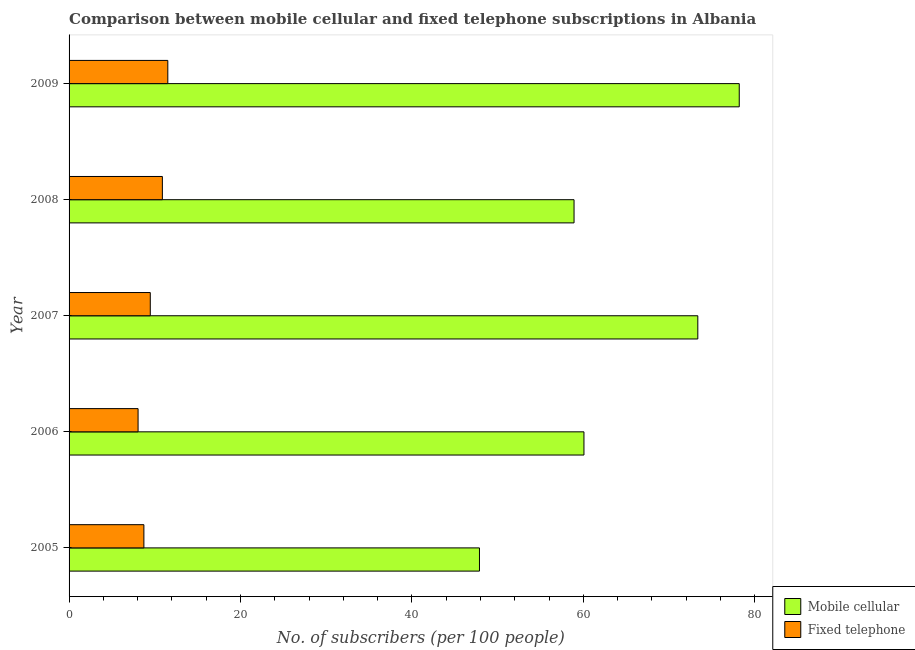How many different coloured bars are there?
Your answer should be very brief. 2. How many bars are there on the 3rd tick from the bottom?
Provide a succinct answer. 2. What is the label of the 4th group of bars from the top?
Offer a very short reply. 2006. What is the number of fixed telephone subscribers in 2005?
Provide a short and direct response. 8.73. Across all years, what is the maximum number of mobile cellular subscribers?
Offer a terse response. 78.18. Across all years, what is the minimum number of fixed telephone subscribers?
Provide a succinct answer. 8.05. In which year was the number of mobile cellular subscribers maximum?
Ensure brevity in your answer.  2009. What is the total number of fixed telephone subscribers in the graph?
Make the answer very short. 48.66. What is the difference between the number of fixed telephone subscribers in 2007 and that in 2009?
Offer a very short reply. -2.04. What is the difference between the number of fixed telephone subscribers in 2008 and the number of mobile cellular subscribers in 2007?
Your answer should be very brief. -62.47. What is the average number of mobile cellular subscribers per year?
Ensure brevity in your answer.  63.68. In the year 2008, what is the difference between the number of mobile cellular subscribers and number of fixed telephone subscribers?
Make the answer very short. 48.03. What is the ratio of the number of fixed telephone subscribers in 2005 to that in 2008?
Ensure brevity in your answer.  0.8. Is the number of fixed telephone subscribers in 2005 less than that in 2007?
Ensure brevity in your answer.  Yes. Is the difference between the number of fixed telephone subscribers in 2005 and 2009 greater than the difference between the number of mobile cellular subscribers in 2005 and 2009?
Your answer should be compact. Yes. What is the difference between the highest and the second highest number of fixed telephone subscribers?
Your answer should be compact. 0.64. What is the difference between the highest and the lowest number of fixed telephone subscribers?
Give a very brief answer. 3.47. In how many years, is the number of fixed telephone subscribers greater than the average number of fixed telephone subscribers taken over all years?
Your answer should be compact. 2. Is the sum of the number of mobile cellular subscribers in 2007 and 2008 greater than the maximum number of fixed telephone subscribers across all years?
Make the answer very short. Yes. What does the 1st bar from the top in 2006 represents?
Ensure brevity in your answer.  Fixed telephone. What does the 2nd bar from the bottom in 2007 represents?
Keep it short and to the point. Fixed telephone. How many bars are there?
Provide a short and direct response. 10. Are all the bars in the graph horizontal?
Make the answer very short. Yes. What is the difference between two consecutive major ticks on the X-axis?
Offer a very short reply. 20. Are the values on the major ticks of X-axis written in scientific E-notation?
Provide a short and direct response. No. How are the legend labels stacked?
Provide a succinct answer. Vertical. What is the title of the graph?
Ensure brevity in your answer.  Comparison between mobile cellular and fixed telephone subscriptions in Albania. What is the label or title of the X-axis?
Ensure brevity in your answer.  No. of subscribers (per 100 people). What is the label or title of the Y-axis?
Give a very brief answer. Year. What is the No. of subscribers (per 100 people) of Mobile cellular in 2005?
Keep it short and to the point. 47.88. What is the No. of subscribers (per 100 people) in Fixed telephone in 2005?
Make the answer very short. 8.73. What is the No. of subscribers (per 100 people) of Mobile cellular in 2006?
Provide a short and direct response. 60.07. What is the No. of subscribers (per 100 people) of Fixed telephone in 2006?
Provide a succinct answer. 8.05. What is the No. of subscribers (per 100 people) in Mobile cellular in 2007?
Keep it short and to the point. 73.35. What is the No. of subscribers (per 100 people) of Fixed telephone in 2007?
Your answer should be very brief. 9.48. What is the No. of subscribers (per 100 people) in Mobile cellular in 2008?
Ensure brevity in your answer.  58.91. What is the No. of subscribers (per 100 people) in Fixed telephone in 2008?
Your answer should be very brief. 10.88. What is the No. of subscribers (per 100 people) in Mobile cellular in 2009?
Offer a very short reply. 78.18. What is the No. of subscribers (per 100 people) in Fixed telephone in 2009?
Make the answer very short. 11.52. Across all years, what is the maximum No. of subscribers (per 100 people) in Mobile cellular?
Your answer should be compact. 78.18. Across all years, what is the maximum No. of subscribers (per 100 people) of Fixed telephone?
Keep it short and to the point. 11.52. Across all years, what is the minimum No. of subscribers (per 100 people) of Mobile cellular?
Ensure brevity in your answer.  47.88. Across all years, what is the minimum No. of subscribers (per 100 people) in Fixed telephone?
Give a very brief answer. 8.05. What is the total No. of subscribers (per 100 people) in Mobile cellular in the graph?
Provide a succinct answer. 318.39. What is the total No. of subscribers (per 100 people) of Fixed telephone in the graph?
Your answer should be very brief. 48.66. What is the difference between the No. of subscribers (per 100 people) in Mobile cellular in 2005 and that in 2006?
Your answer should be compact. -12.19. What is the difference between the No. of subscribers (per 100 people) of Fixed telephone in 2005 and that in 2006?
Your response must be concise. 0.68. What is the difference between the No. of subscribers (per 100 people) in Mobile cellular in 2005 and that in 2007?
Provide a short and direct response. -25.47. What is the difference between the No. of subscribers (per 100 people) in Fixed telephone in 2005 and that in 2007?
Your answer should be very brief. -0.75. What is the difference between the No. of subscribers (per 100 people) of Mobile cellular in 2005 and that in 2008?
Keep it short and to the point. -11.03. What is the difference between the No. of subscribers (per 100 people) of Fixed telephone in 2005 and that in 2008?
Provide a short and direct response. -2.16. What is the difference between the No. of subscribers (per 100 people) of Mobile cellular in 2005 and that in 2009?
Provide a short and direct response. -30.31. What is the difference between the No. of subscribers (per 100 people) of Fixed telephone in 2005 and that in 2009?
Make the answer very short. -2.79. What is the difference between the No. of subscribers (per 100 people) of Mobile cellular in 2006 and that in 2007?
Ensure brevity in your answer.  -13.28. What is the difference between the No. of subscribers (per 100 people) of Fixed telephone in 2006 and that in 2007?
Make the answer very short. -1.42. What is the difference between the No. of subscribers (per 100 people) of Mobile cellular in 2006 and that in 2008?
Your answer should be compact. 1.16. What is the difference between the No. of subscribers (per 100 people) in Fixed telephone in 2006 and that in 2008?
Provide a short and direct response. -2.83. What is the difference between the No. of subscribers (per 100 people) of Mobile cellular in 2006 and that in 2009?
Keep it short and to the point. -18.12. What is the difference between the No. of subscribers (per 100 people) in Fixed telephone in 2006 and that in 2009?
Ensure brevity in your answer.  -3.47. What is the difference between the No. of subscribers (per 100 people) in Mobile cellular in 2007 and that in 2008?
Your response must be concise. 14.44. What is the difference between the No. of subscribers (per 100 people) in Fixed telephone in 2007 and that in 2008?
Provide a succinct answer. -1.41. What is the difference between the No. of subscribers (per 100 people) in Mobile cellular in 2007 and that in 2009?
Make the answer very short. -4.83. What is the difference between the No. of subscribers (per 100 people) in Fixed telephone in 2007 and that in 2009?
Offer a terse response. -2.04. What is the difference between the No. of subscribers (per 100 people) of Mobile cellular in 2008 and that in 2009?
Your answer should be very brief. -19.27. What is the difference between the No. of subscribers (per 100 people) of Fixed telephone in 2008 and that in 2009?
Make the answer very short. -0.63. What is the difference between the No. of subscribers (per 100 people) in Mobile cellular in 2005 and the No. of subscribers (per 100 people) in Fixed telephone in 2006?
Offer a very short reply. 39.83. What is the difference between the No. of subscribers (per 100 people) of Mobile cellular in 2005 and the No. of subscribers (per 100 people) of Fixed telephone in 2007?
Give a very brief answer. 38.4. What is the difference between the No. of subscribers (per 100 people) in Mobile cellular in 2005 and the No. of subscribers (per 100 people) in Fixed telephone in 2008?
Make the answer very short. 36.99. What is the difference between the No. of subscribers (per 100 people) of Mobile cellular in 2005 and the No. of subscribers (per 100 people) of Fixed telephone in 2009?
Provide a succinct answer. 36.36. What is the difference between the No. of subscribers (per 100 people) in Mobile cellular in 2006 and the No. of subscribers (per 100 people) in Fixed telephone in 2007?
Your response must be concise. 50.59. What is the difference between the No. of subscribers (per 100 people) in Mobile cellular in 2006 and the No. of subscribers (per 100 people) in Fixed telephone in 2008?
Offer a very short reply. 49.18. What is the difference between the No. of subscribers (per 100 people) in Mobile cellular in 2006 and the No. of subscribers (per 100 people) in Fixed telephone in 2009?
Your answer should be very brief. 48.55. What is the difference between the No. of subscribers (per 100 people) of Mobile cellular in 2007 and the No. of subscribers (per 100 people) of Fixed telephone in 2008?
Provide a succinct answer. 62.47. What is the difference between the No. of subscribers (per 100 people) of Mobile cellular in 2007 and the No. of subscribers (per 100 people) of Fixed telephone in 2009?
Keep it short and to the point. 61.83. What is the difference between the No. of subscribers (per 100 people) of Mobile cellular in 2008 and the No. of subscribers (per 100 people) of Fixed telephone in 2009?
Keep it short and to the point. 47.39. What is the average No. of subscribers (per 100 people) of Mobile cellular per year?
Make the answer very short. 63.68. What is the average No. of subscribers (per 100 people) of Fixed telephone per year?
Ensure brevity in your answer.  9.73. In the year 2005, what is the difference between the No. of subscribers (per 100 people) in Mobile cellular and No. of subscribers (per 100 people) in Fixed telephone?
Keep it short and to the point. 39.15. In the year 2006, what is the difference between the No. of subscribers (per 100 people) of Mobile cellular and No. of subscribers (per 100 people) of Fixed telephone?
Your answer should be compact. 52.02. In the year 2007, what is the difference between the No. of subscribers (per 100 people) of Mobile cellular and No. of subscribers (per 100 people) of Fixed telephone?
Keep it short and to the point. 63.88. In the year 2008, what is the difference between the No. of subscribers (per 100 people) of Mobile cellular and No. of subscribers (per 100 people) of Fixed telephone?
Provide a succinct answer. 48.03. In the year 2009, what is the difference between the No. of subscribers (per 100 people) of Mobile cellular and No. of subscribers (per 100 people) of Fixed telephone?
Offer a very short reply. 66.67. What is the ratio of the No. of subscribers (per 100 people) of Mobile cellular in 2005 to that in 2006?
Your answer should be very brief. 0.8. What is the ratio of the No. of subscribers (per 100 people) in Fixed telephone in 2005 to that in 2006?
Offer a very short reply. 1.08. What is the ratio of the No. of subscribers (per 100 people) in Mobile cellular in 2005 to that in 2007?
Provide a short and direct response. 0.65. What is the ratio of the No. of subscribers (per 100 people) of Fixed telephone in 2005 to that in 2007?
Offer a very short reply. 0.92. What is the ratio of the No. of subscribers (per 100 people) in Mobile cellular in 2005 to that in 2008?
Your response must be concise. 0.81. What is the ratio of the No. of subscribers (per 100 people) in Fixed telephone in 2005 to that in 2008?
Your answer should be compact. 0.8. What is the ratio of the No. of subscribers (per 100 people) in Mobile cellular in 2005 to that in 2009?
Your response must be concise. 0.61. What is the ratio of the No. of subscribers (per 100 people) in Fixed telephone in 2005 to that in 2009?
Give a very brief answer. 0.76. What is the ratio of the No. of subscribers (per 100 people) of Mobile cellular in 2006 to that in 2007?
Offer a very short reply. 0.82. What is the ratio of the No. of subscribers (per 100 people) in Fixed telephone in 2006 to that in 2007?
Keep it short and to the point. 0.85. What is the ratio of the No. of subscribers (per 100 people) in Mobile cellular in 2006 to that in 2008?
Offer a terse response. 1.02. What is the ratio of the No. of subscribers (per 100 people) of Fixed telephone in 2006 to that in 2008?
Give a very brief answer. 0.74. What is the ratio of the No. of subscribers (per 100 people) of Mobile cellular in 2006 to that in 2009?
Your answer should be compact. 0.77. What is the ratio of the No. of subscribers (per 100 people) in Fixed telephone in 2006 to that in 2009?
Provide a succinct answer. 0.7. What is the ratio of the No. of subscribers (per 100 people) of Mobile cellular in 2007 to that in 2008?
Your response must be concise. 1.25. What is the ratio of the No. of subscribers (per 100 people) of Fixed telephone in 2007 to that in 2008?
Ensure brevity in your answer.  0.87. What is the ratio of the No. of subscribers (per 100 people) of Mobile cellular in 2007 to that in 2009?
Give a very brief answer. 0.94. What is the ratio of the No. of subscribers (per 100 people) of Fixed telephone in 2007 to that in 2009?
Give a very brief answer. 0.82. What is the ratio of the No. of subscribers (per 100 people) in Mobile cellular in 2008 to that in 2009?
Offer a terse response. 0.75. What is the ratio of the No. of subscribers (per 100 people) of Fixed telephone in 2008 to that in 2009?
Make the answer very short. 0.94. What is the difference between the highest and the second highest No. of subscribers (per 100 people) in Mobile cellular?
Your answer should be very brief. 4.83. What is the difference between the highest and the second highest No. of subscribers (per 100 people) in Fixed telephone?
Give a very brief answer. 0.63. What is the difference between the highest and the lowest No. of subscribers (per 100 people) in Mobile cellular?
Offer a very short reply. 30.31. What is the difference between the highest and the lowest No. of subscribers (per 100 people) in Fixed telephone?
Ensure brevity in your answer.  3.47. 